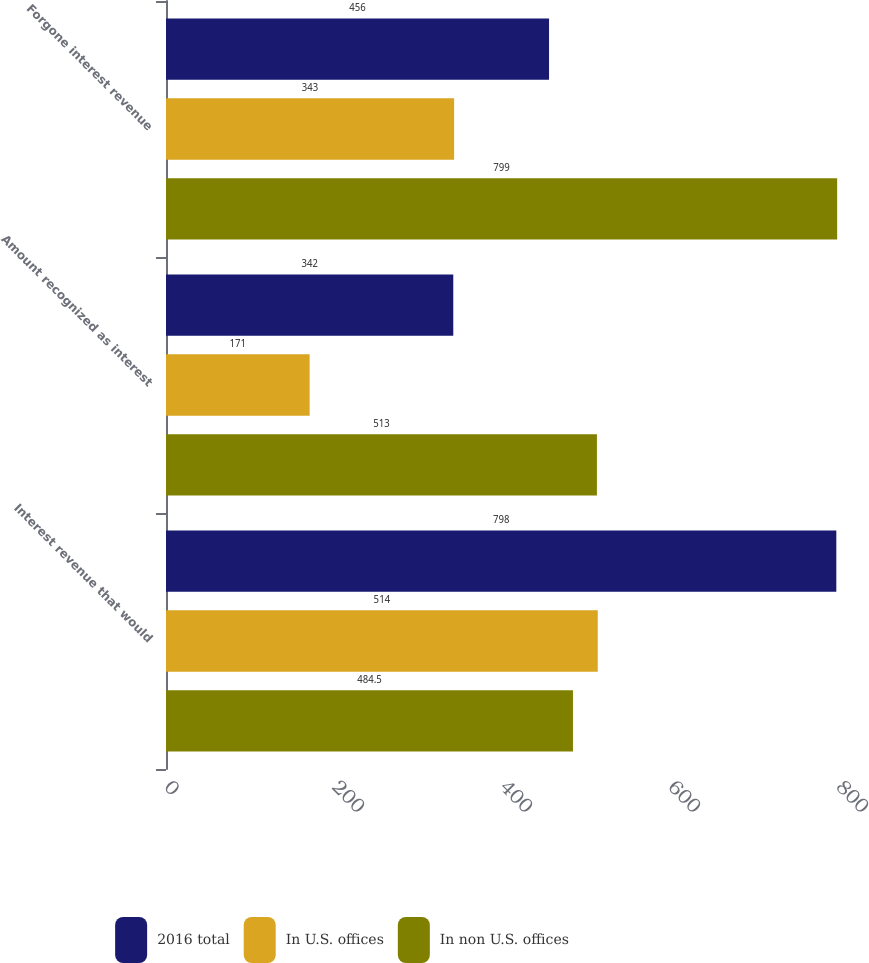Convert chart to OTSL. <chart><loc_0><loc_0><loc_500><loc_500><stacked_bar_chart><ecel><fcel>Interest revenue that would<fcel>Amount recognized as interest<fcel>Forgone interest revenue<nl><fcel>2016 total<fcel>798<fcel>342<fcel>456<nl><fcel>In U.S. offices<fcel>514<fcel>171<fcel>343<nl><fcel>In non U.S. offices<fcel>484.5<fcel>513<fcel>799<nl></chart> 